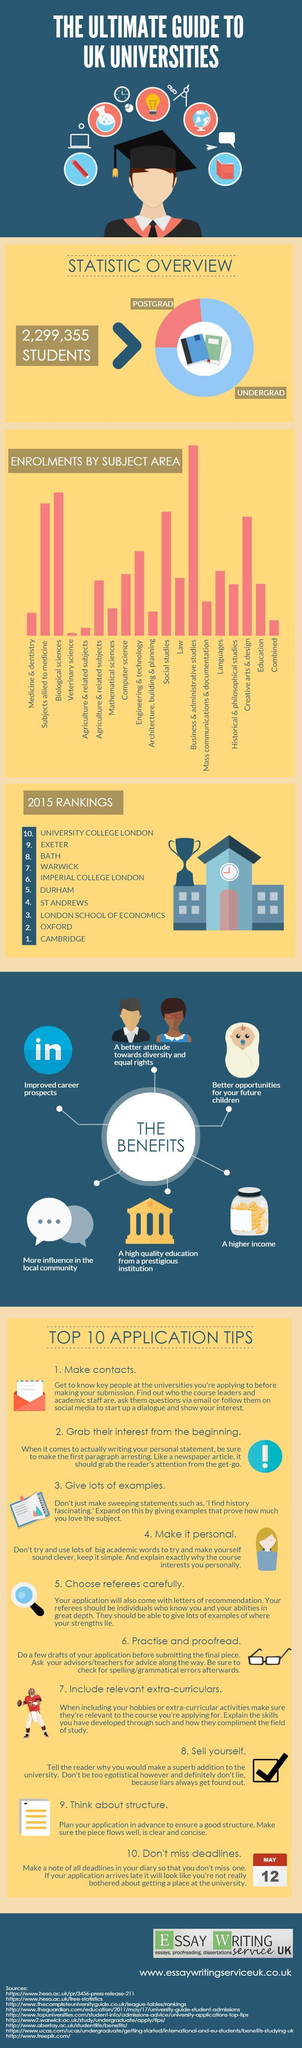In which area enrolment by subject is the lowest?
Answer the question with a short phrase. Veterinary science In which area enrolment by subject is the second lowest? Agriculture & related subjects In which area enrolment by subject is the second highest? Biological sciences In which area enrolment by subject is the highest? Business & administrative studies 